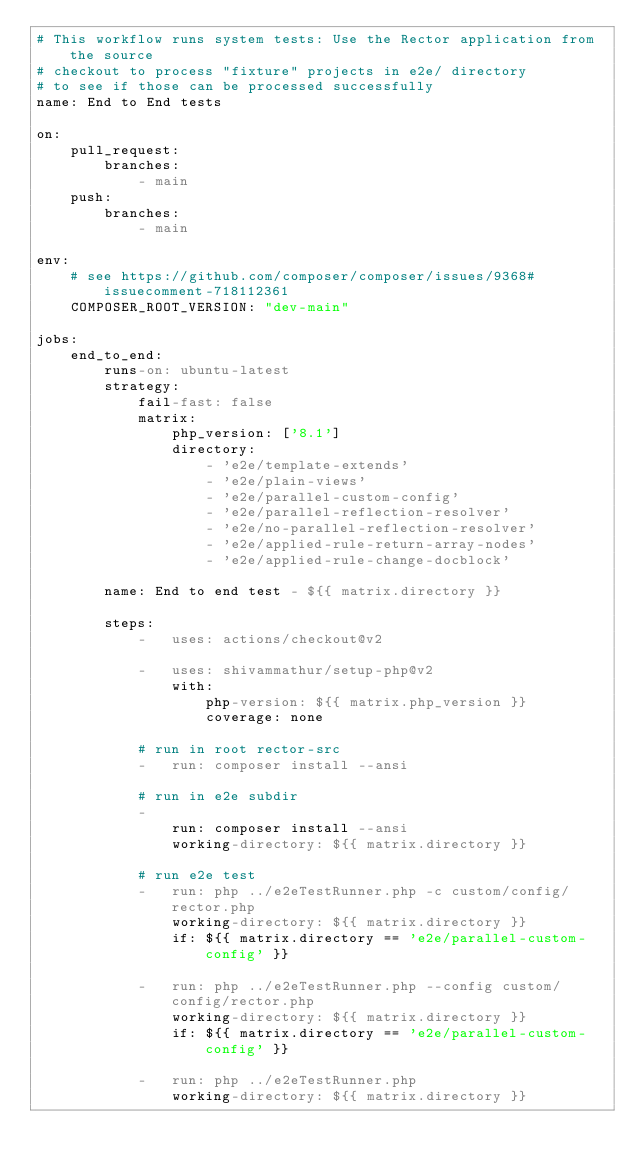Convert code to text. <code><loc_0><loc_0><loc_500><loc_500><_YAML_># This workflow runs system tests: Use the Rector application from the source
# checkout to process "fixture" projects in e2e/ directory
# to see if those can be processed successfully
name: End to End tests

on:
    pull_request:
        branches:
            - main
    push:
        branches:
            - main

env:
    # see https://github.com/composer/composer/issues/9368#issuecomment-718112361
    COMPOSER_ROOT_VERSION: "dev-main"

jobs:
    end_to_end:
        runs-on: ubuntu-latest
        strategy:
            fail-fast: false
            matrix:
                php_version: ['8.1']
                directory:
                    - 'e2e/template-extends'
                    - 'e2e/plain-views'
                    - 'e2e/parallel-custom-config'
                    - 'e2e/parallel-reflection-resolver'
                    - 'e2e/no-parallel-reflection-resolver'
                    - 'e2e/applied-rule-return-array-nodes'
                    - 'e2e/applied-rule-change-docblock'

        name: End to end test - ${{ matrix.directory }}

        steps:
            -   uses: actions/checkout@v2

            -   uses: shivammathur/setup-php@v2
                with:
                    php-version: ${{ matrix.php_version }}
                    coverage: none

            # run in root rector-src
            -   run: composer install --ansi

            # run in e2e subdir
            -
                run: composer install --ansi
                working-directory: ${{ matrix.directory }}

            # run e2e test
            -   run: php ../e2eTestRunner.php -c custom/config/rector.php
                working-directory: ${{ matrix.directory }}
                if: ${{ matrix.directory == 'e2e/parallel-custom-config' }}

            -   run: php ../e2eTestRunner.php --config custom/config/rector.php
                working-directory: ${{ matrix.directory }}
                if: ${{ matrix.directory == 'e2e/parallel-custom-config' }}

            -   run: php ../e2eTestRunner.php
                working-directory: ${{ matrix.directory }}</code> 